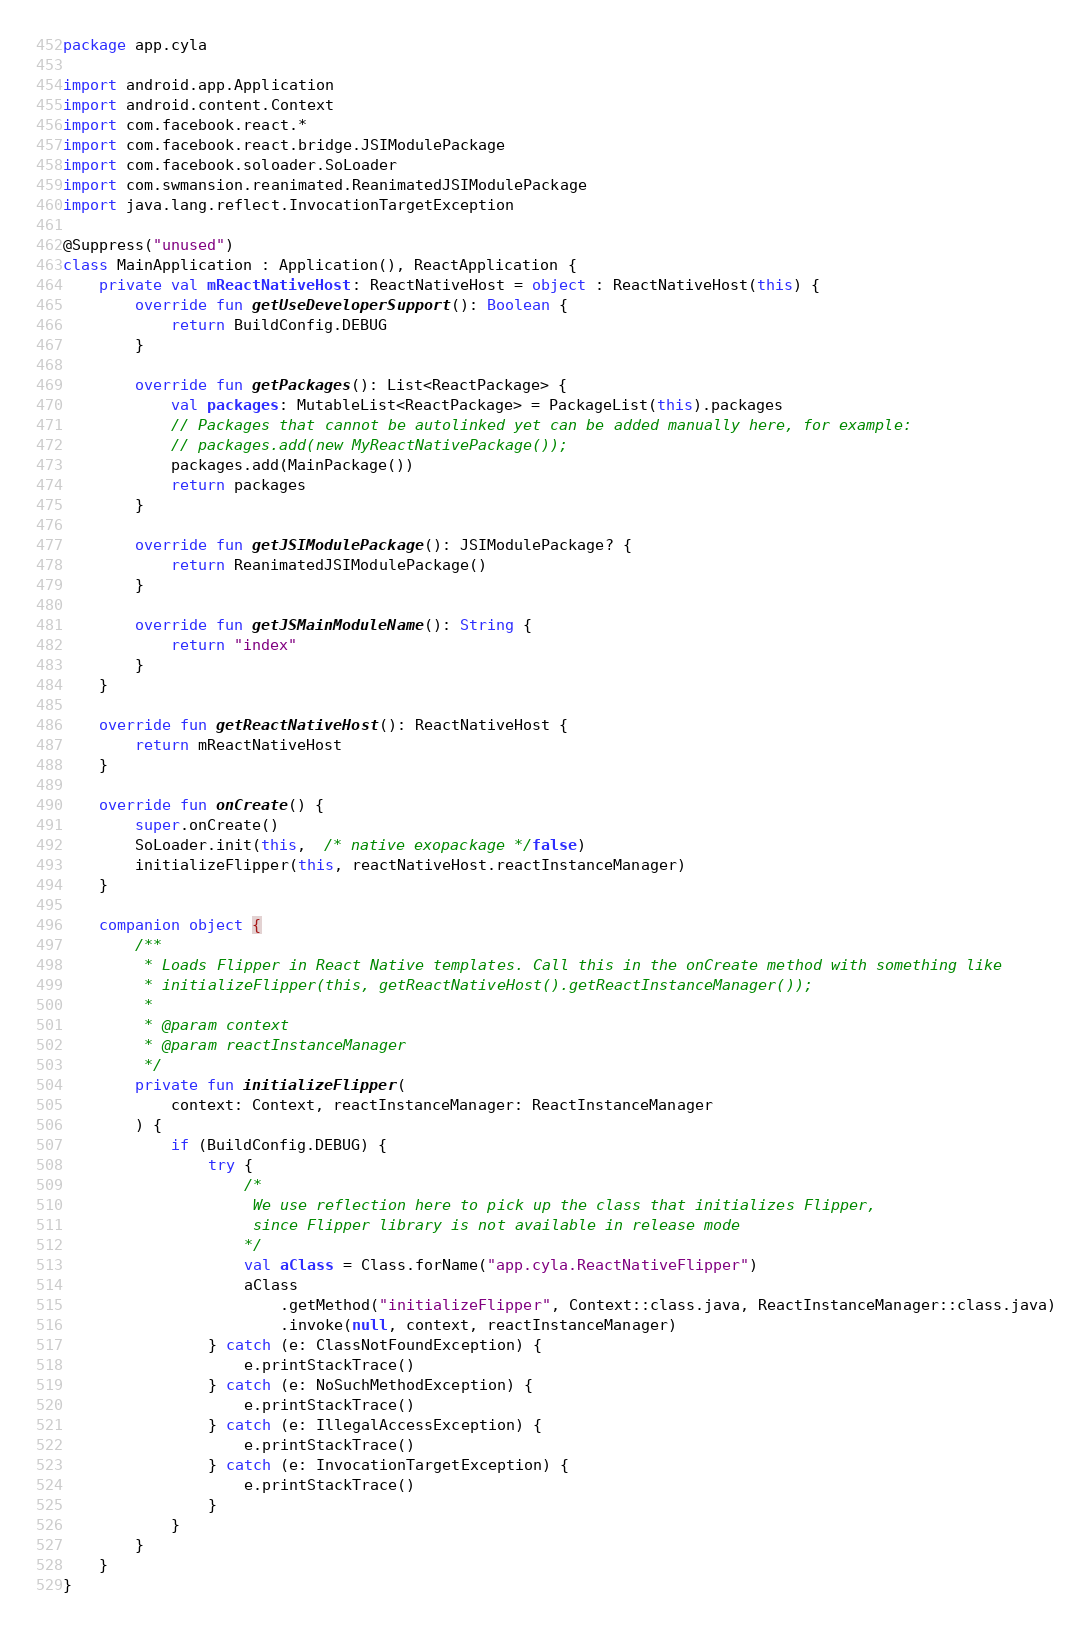<code> <loc_0><loc_0><loc_500><loc_500><_Kotlin_>package app.cyla

import android.app.Application
import android.content.Context
import com.facebook.react.*
import com.facebook.react.bridge.JSIModulePackage
import com.facebook.soloader.SoLoader
import com.swmansion.reanimated.ReanimatedJSIModulePackage
import java.lang.reflect.InvocationTargetException

@Suppress("unused")
class MainApplication : Application(), ReactApplication {
    private val mReactNativeHost: ReactNativeHost = object : ReactNativeHost(this) {
        override fun getUseDeveloperSupport(): Boolean {
            return BuildConfig.DEBUG
        }

        override fun getPackages(): List<ReactPackage> {
            val packages: MutableList<ReactPackage> = PackageList(this).packages
            // Packages that cannot be autolinked yet can be added manually here, for example:
            // packages.add(new MyReactNativePackage());
            packages.add(MainPackage())
            return packages
        }

        override fun getJSIModulePackage(): JSIModulePackage? {
            return ReanimatedJSIModulePackage()
        }

        override fun getJSMainModuleName(): String {
            return "index"
        }
    }

    override fun getReactNativeHost(): ReactNativeHost {
        return mReactNativeHost
    }

    override fun onCreate() {
        super.onCreate()
        SoLoader.init(this,  /* native exopackage */false)
        initializeFlipper(this, reactNativeHost.reactInstanceManager)
    }

    companion object {
        /**
         * Loads Flipper in React Native templates. Call this in the onCreate method with something like
         * initializeFlipper(this, getReactNativeHost().getReactInstanceManager());
         *
         * @param context
         * @param reactInstanceManager
         */
        private fun initializeFlipper(
            context: Context, reactInstanceManager: ReactInstanceManager
        ) {
            if (BuildConfig.DEBUG) {
                try {
                    /*
                     We use reflection here to pick up the class that initializes Flipper,
                     since Flipper library is not available in release mode
                    */
                    val aClass = Class.forName("app.cyla.ReactNativeFlipper")
                    aClass
                        .getMethod("initializeFlipper", Context::class.java, ReactInstanceManager::class.java)
                        .invoke(null, context, reactInstanceManager)
                } catch (e: ClassNotFoundException) {
                    e.printStackTrace()
                } catch (e: NoSuchMethodException) {
                    e.printStackTrace()
                } catch (e: IllegalAccessException) {
                    e.printStackTrace()
                } catch (e: InvocationTargetException) {
                    e.printStackTrace()
                }
            }
        }
    }
}
</code> 